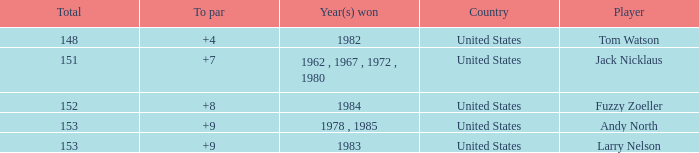What is the Total of the Player with a To par of 4? 1.0. 